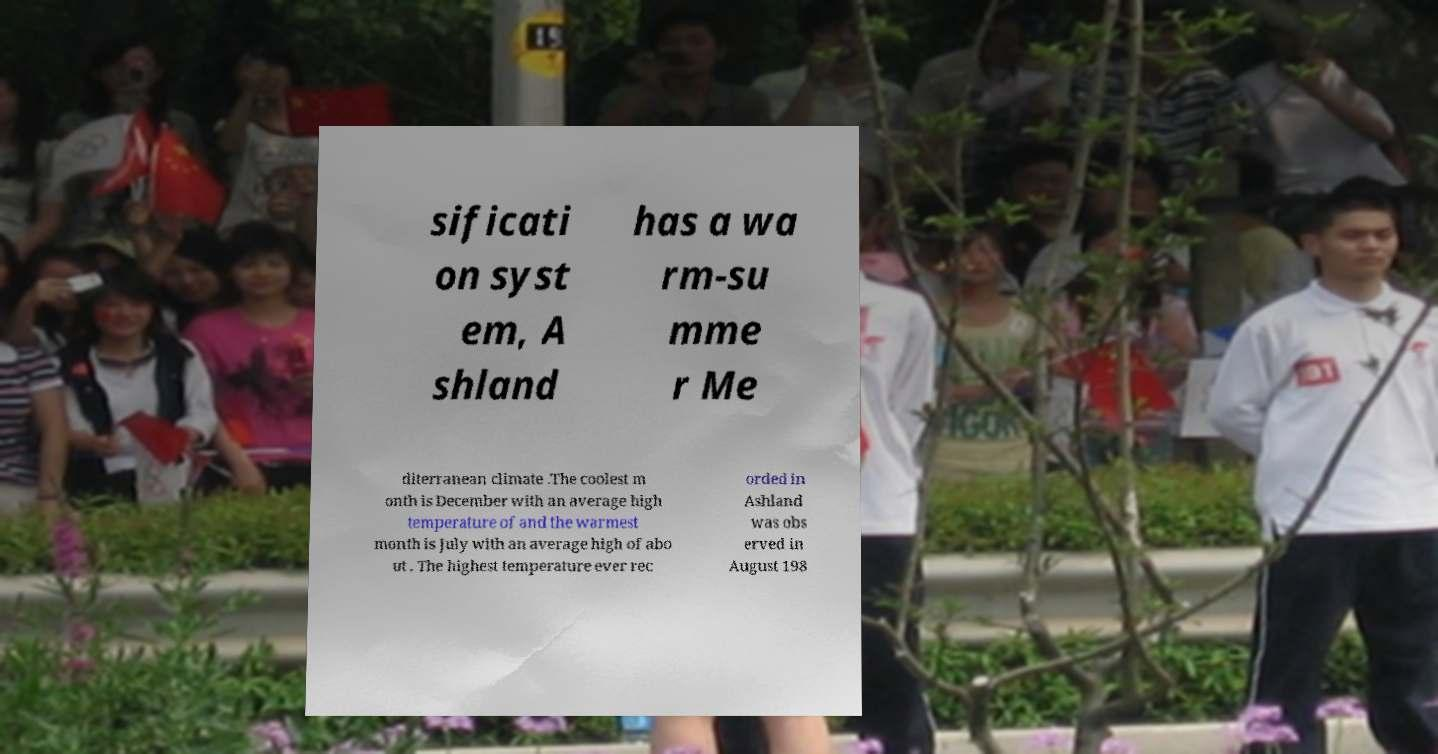For documentation purposes, I need the text within this image transcribed. Could you provide that? sificati on syst em, A shland has a wa rm-su mme r Me diterranean climate .The coolest m onth is December with an average high temperature of and the warmest month is July with an average high of abo ut . The highest temperature ever rec orded in Ashland was obs erved in August 198 